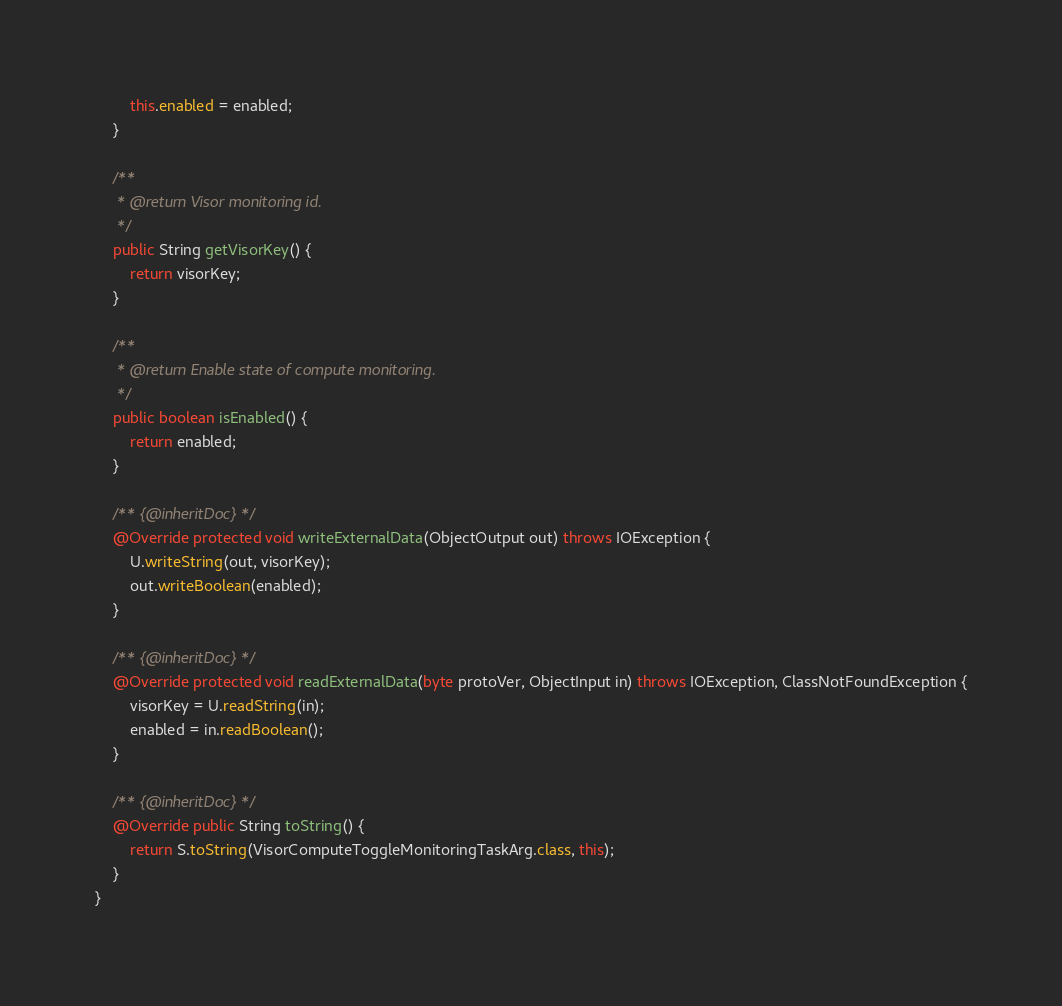<code> <loc_0><loc_0><loc_500><loc_500><_Java_>        this.enabled = enabled;
    }

    /**
     * @return Visor monitoring id.
     */
    public String getVisorKey() {
        return visorKey;
    }

    /**
     * @return Enable state of compute monitoring.
     */
    public boolean isEnabled() {
        return enabled;
    }

    /** {@inheritDoc} */
    @Override protected void writeExternalData(ObjectOutput out) throws IOException {
        U.writeString(out, visorKey);
        out.writeBoolean(enabled);
    }

    /** {@inheritDoc} */
    @Override protected void readExternalData(byte protoVer, ObjectInput in) throws IOException, ClassNotFoundException {
        visorKey = U.readString(in);
        enabled = in.readBoolean();
    }

    /** {@inheritDoc} */
    @Override public String toString() {
        return S.toString(VisorComputeToggleMonitoringTaskArg.class, this);
    }
}
</code> 